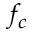Convert formula to latex. <formula><loc_0><loc_0><loc_500><loc_500>f _ { c }</formula> 